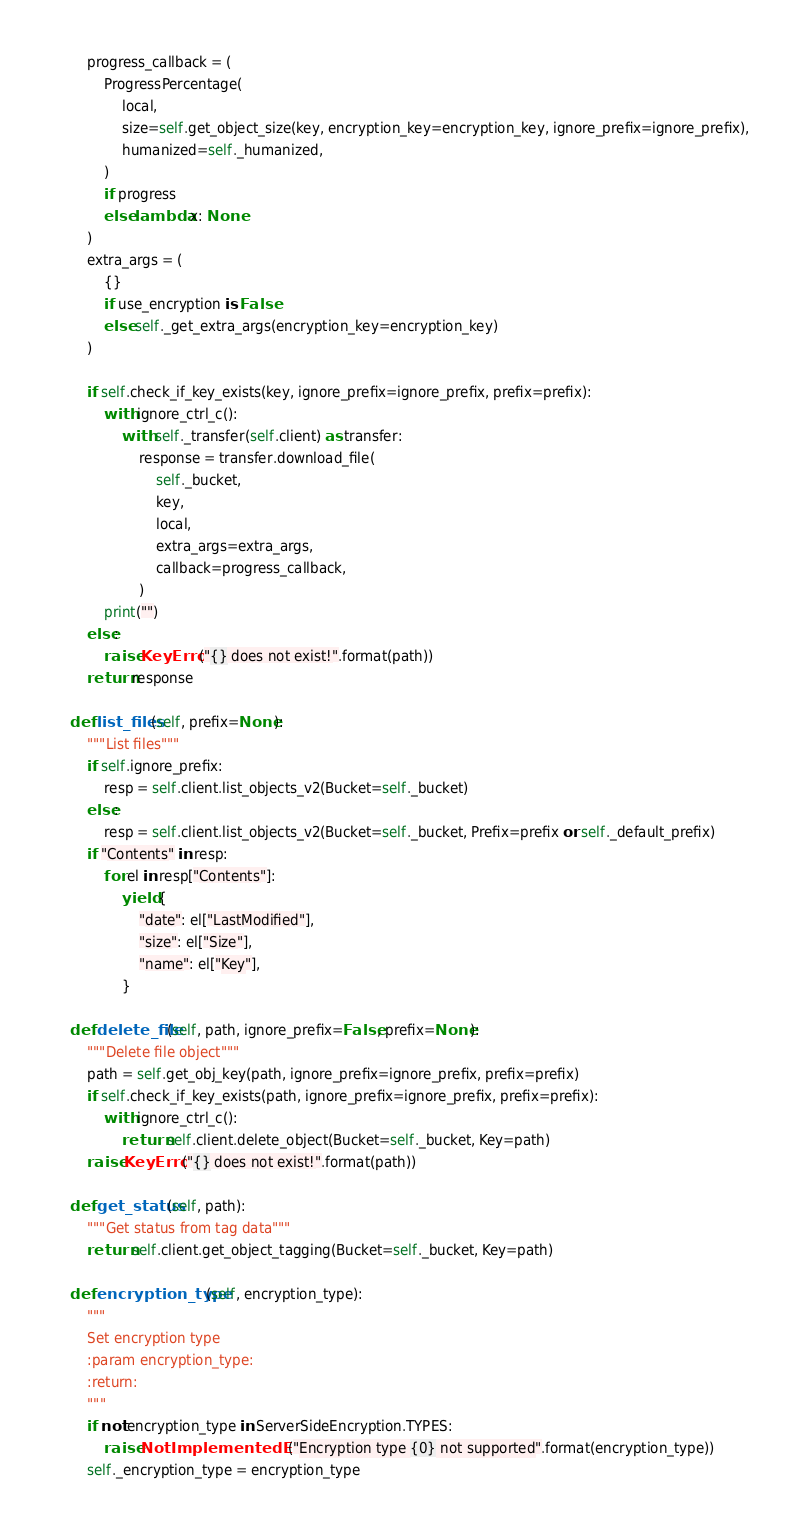<code> <loc_0><loc_0><loc_500><loc_500><_Python_>
        progress_callback = (
            ProgressPercentage(
                local,
                size=self.get_object_size(key, encryption_key=encryption_key, ignore_prefix=ignore_prefix),
                humanized=self._humanized,
            )
            if progress
            else lambda x: None
        )
        extra_args = (
            {}
            if use_encryption is False
            else self._get_extra_args(encryption_key=encryption_key)
        )

        if self.check_if_key_exists(key, ignore_prefix=ignore_prefix, prefix=prefix):
            with ignore_ctrl_c():
                with self._transfer(self.client) as transfer:
                    response = transfer.download_file(
                        self._bucket,
                        key,
                        local,
                        extra_args=extra_args,
                        callback=progress_callback,
                    )
            print("")
        else:
            raise KeyError("{} does not exist!".format(path))
        return response

    def list_files(self, prefix=None):
        """List files"""
        if self.ignore_prefix:
            resp = self.client.list_objects_v2(Bucket=self._bucket)
        else:
            resp = self.client.list_objects_v2(Bucket=self._bucket, Prefix=prefix or self._default_prefix)
        if "Contents" in resp:
            for el in resp["Contents"]:
                yield {
                    "date": el["LastModified"],
                    "size": el["Size"],
                    "name": el["Key"],
                }

    def delete_file(self, path, ignore_prefix=False, prefix=None):
        """Delete file object"""
        path = self.get_obj_key(path, ignore_prefix=ignore_prefix, prefix=prefix)
        if self.check_if_key_exists(path, ignore_prefix=ignore_prefix, prefix=prefix):
            with ignore_ctrl_c():
                return self.client.delete_object(Bucket=self._bucket, Key=path)
        raise KeyError("{} does not exist!".format(path))

    def get_status(self, path):
        """Get status from tag data"""
        return self.client.get_object_tagging(Bucket=self._bucket, Key=path)

    def encryption_type(self, encryption_type):
        """
        Set encryption type
        :param encryption_type:
        :return:
        """
        if not encryption_type in ServerSideEncryption.TYPES:
            raise NotImplementedError("Encryption type {0} not supported".format(encryption_type))
        self._encryption_type = encryption_type
</code> 